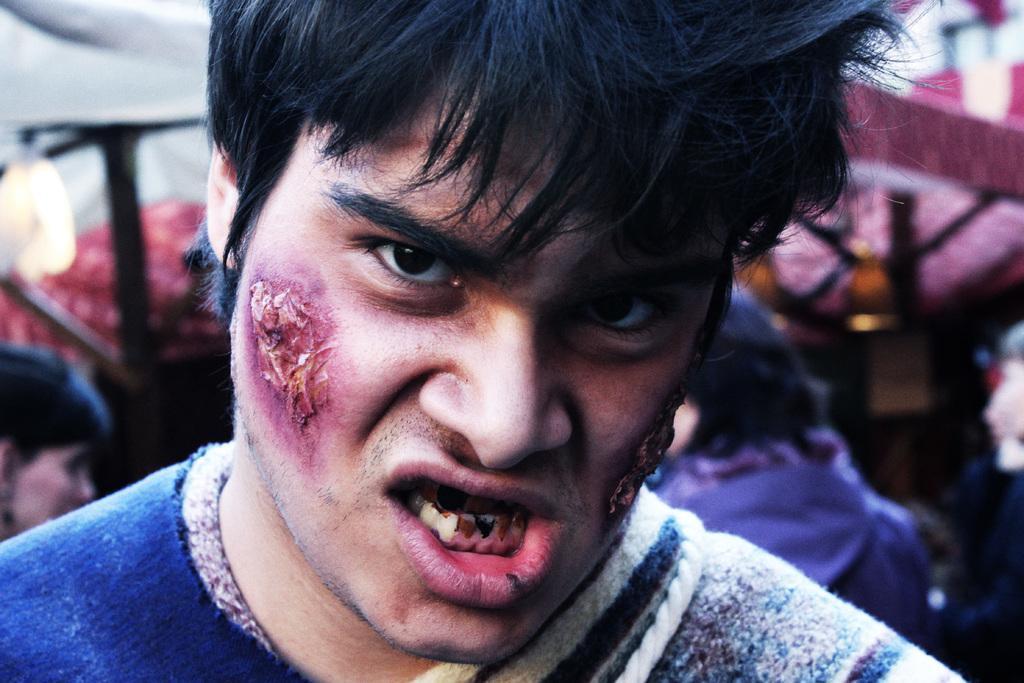In one or two sentences, can you explain what this image depicts? In this image we can see a man. In the background the image is blur but we can see few persons and objects. 